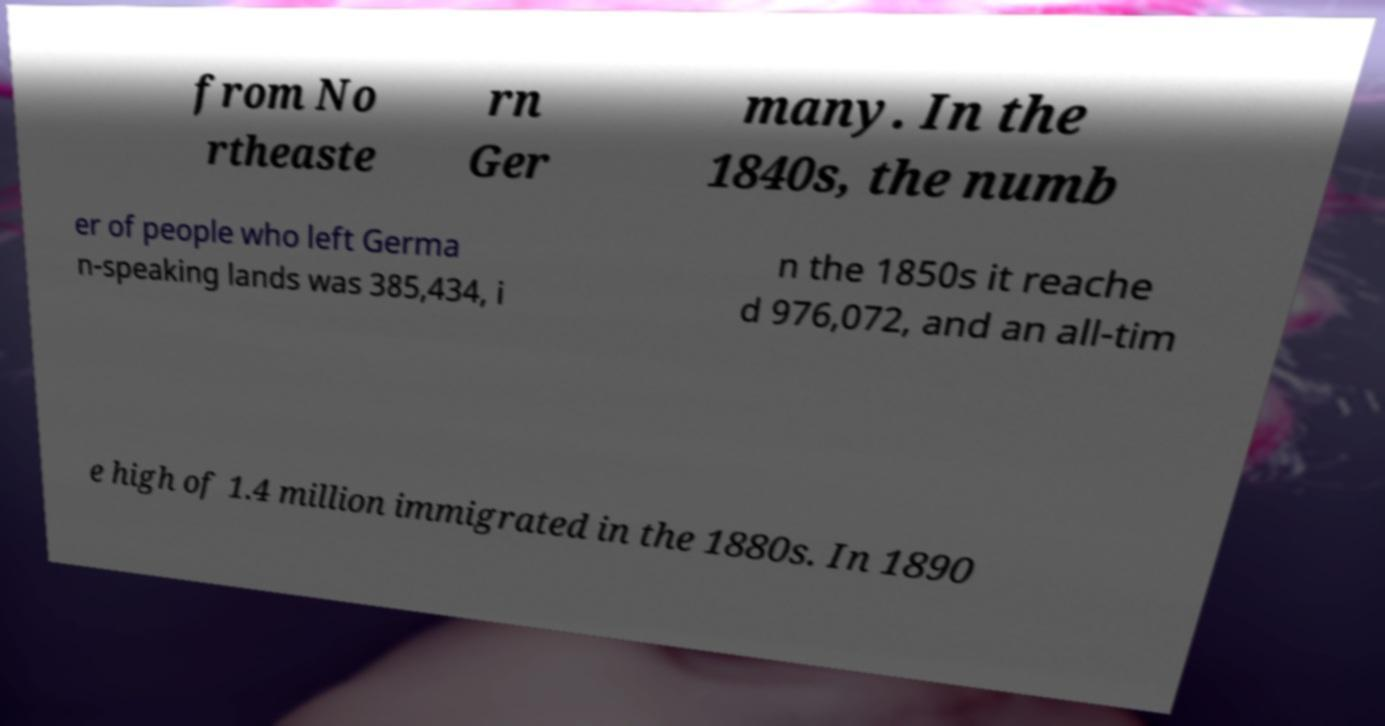Could you extract and type out the text from this image? from No rtheaste rn Ger many. In the 1840s, the numb er of people who left Germa n-speaking lands was 385,434, i n the 1850s it reache d 976,072, and an all-tim e high of 1.4 million immigrated in the 1880s. In 1890 